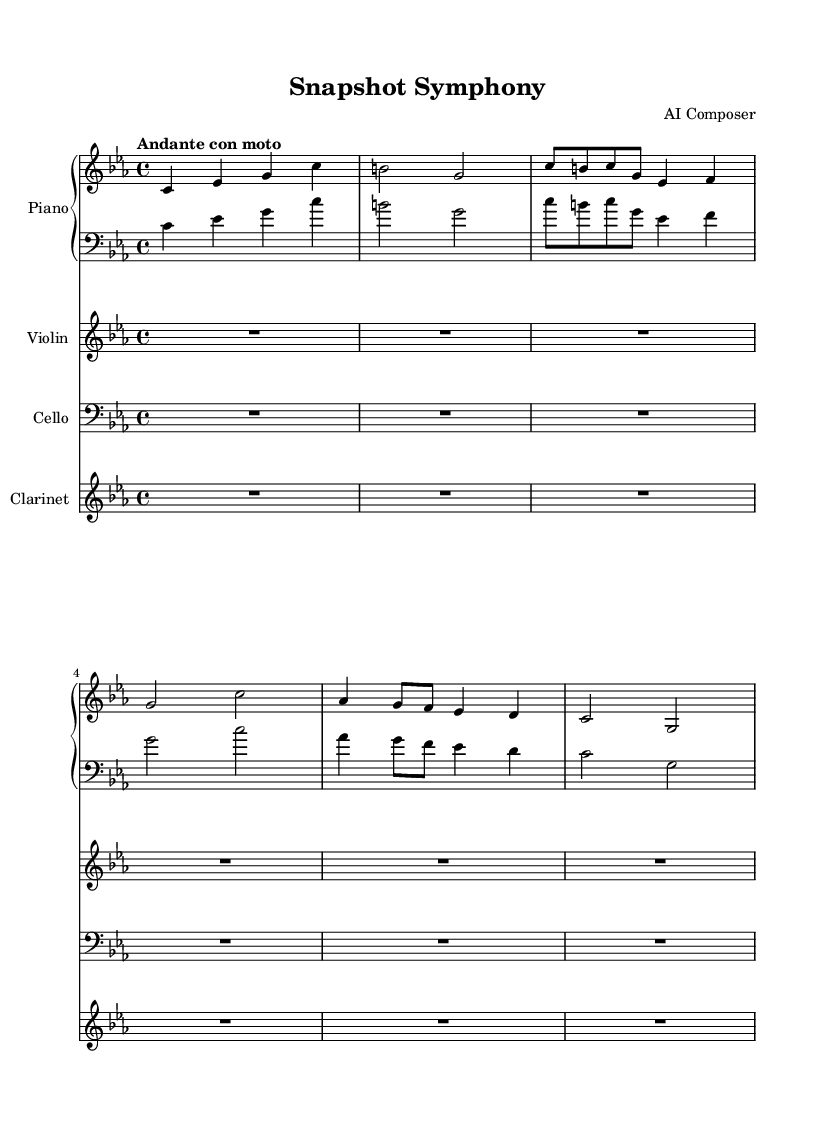What is the key signature of this music? The key signature indicated at the beginning of the score shows three flats, which corresponds to C minor.
Answer: C minor What is the time signature of this music? The time signature displayed in the score is 4/4, meaning there are four beats in each measure and a quarter note receives one beat.
Answer: 4/4 What is the tempo marking for this composition? The tempo marking provided at the beginning of the score is "Andante con moto," which suggests a moderately slow tempo with a movement.
Answer: Andante con moto How many parts are there in this score? The score consists of four distinct parts: Piano, Violin, Cello, and Clarinet, as defined in the individual staves.
Answer: Four Which instrument does not have any notes written in this score? The instrument parts such as Violin, Cello, and Clarinet all have rest indicators, but the Clarinet part displays a whole rest throughout the score, indicating silence.
Answer: Clarinet What is the first theme presented in the score? The first theme presented is Theme A, starting with the notes C, B, C, G, E-flat that appear after the introduction.
Answer: Theme A 